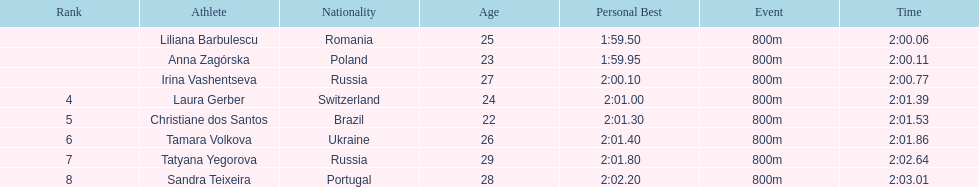The last runner crossed the finish line in 2:03.01. what was the previous time for the 7th runner? 2:02.64. 